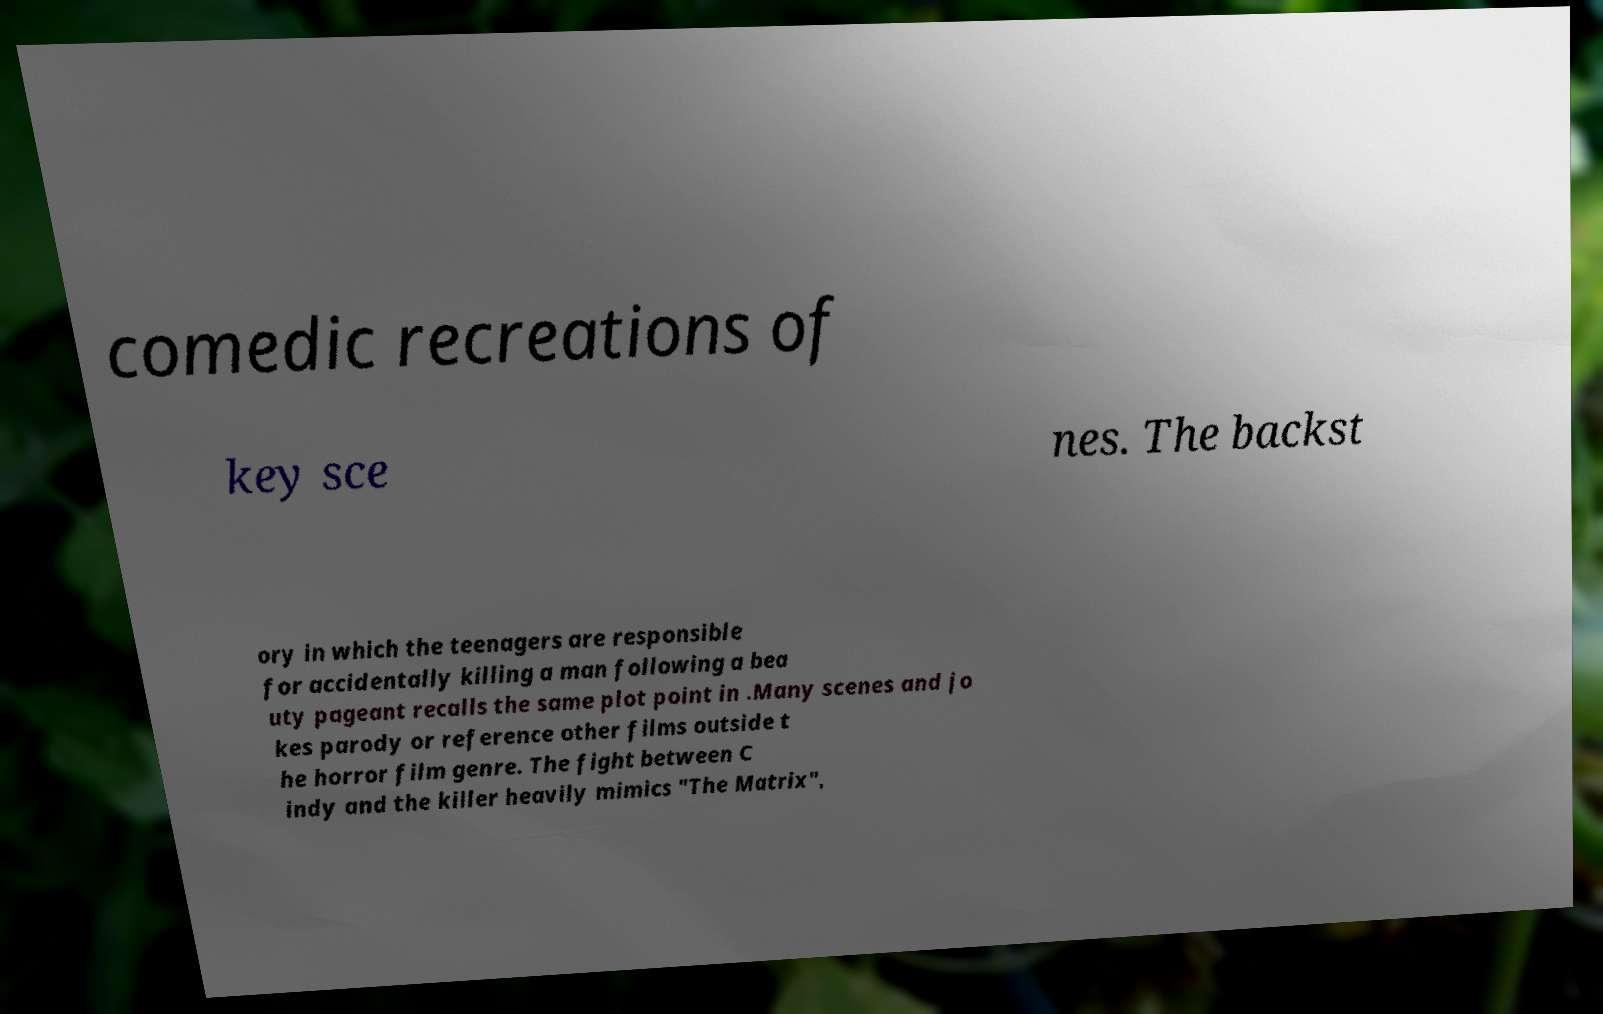For documentation purposes, I need the text within this image transcribed. Could you provide that? comedic recreations of key sce nes. The backst ory in which the teenagers are responsible for accidentally killing a man following a bea uty pageant recalls the same plot point in .Many scenes and jo kes parody or reference other films outside t he horror film genre. The fight between C indy and the killer heavily mimics "The Matrix", 